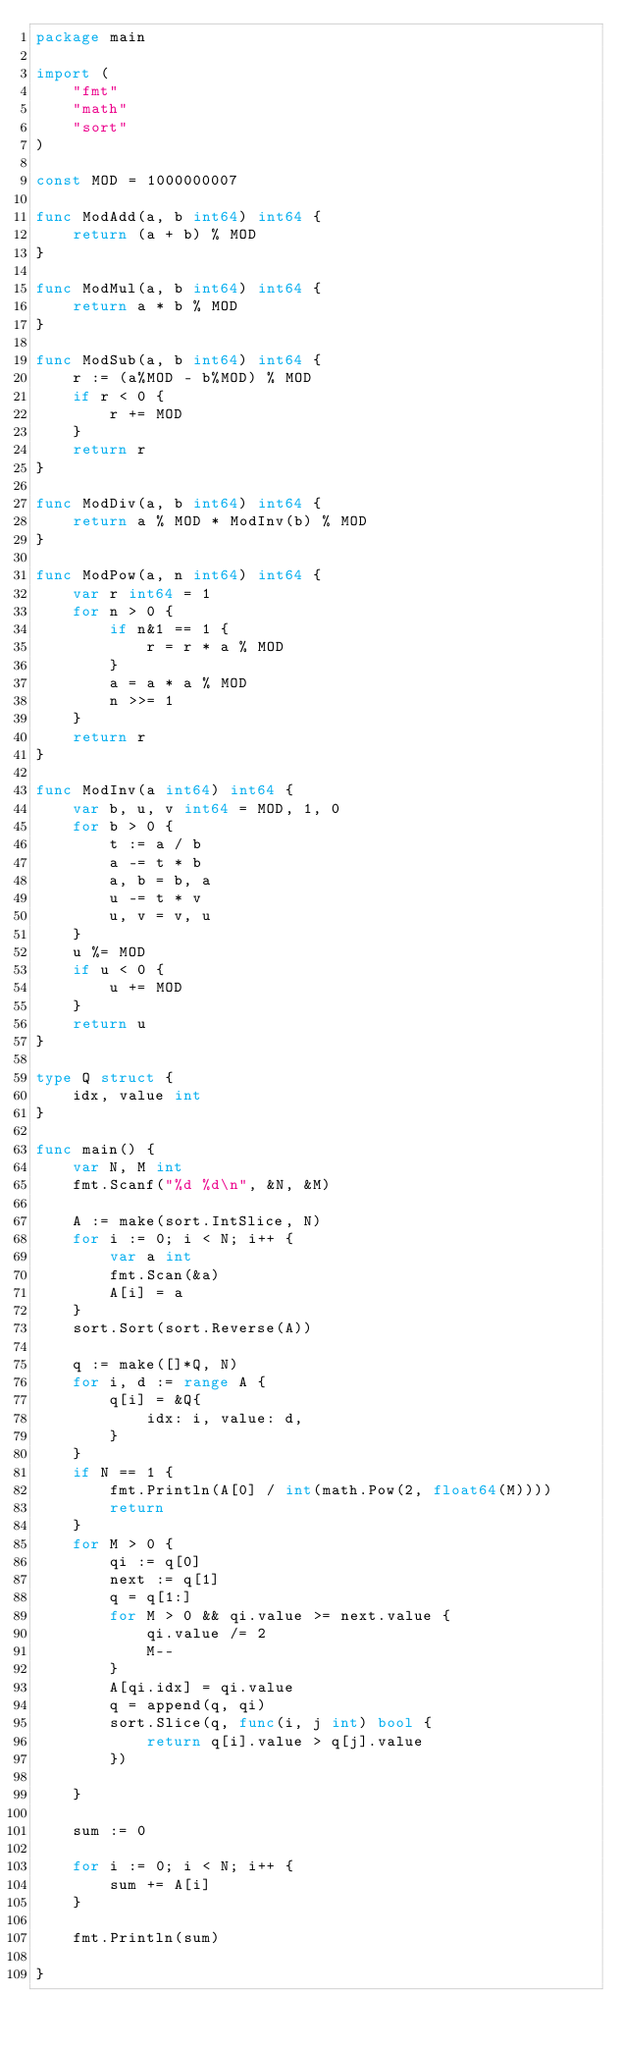Convert code to text. <code><loc_0><loc_0><loc_500><loc_500><_Go_>package main

import (
	"fmt"
	"math"
	"sort"
)

const MOD = 1000000007

func ModAdd(a, b int64) int64 {
	return (a + b) % MOD
}

func ModMul(a, b int64) int64 {
	return a * b % MOD
}

func ModSub(a, b int64) int64 {
	r := (a%MOD - b%MOD) % MOD
	if r < 0 {
		r += MOD
	}
	return r
}

func ModDiv(a, b int64) int64 {
	return a % MOD * ModInv(b) % MOD
}

func ModPow(a, n int64) int64 {
	var r int64 = 1
	for n > 0 {
		if n&1 == 1 {
			r = r * a % MOD
		}
		a = a * a % MOD
		n >>= 1
	}
	return r
}

func ModInv(a int64) int64 {
	var b, u, v int64 = MOD, 1, 0
	for b > 0 {
		t := a / b
		a -= t * b
		a, b = b, a
		u -= t * v
		u, v = v, u
	}
	u %= MOD
	if u < 0 {
		u += MOD
	}
	return u
}

type Q struct {
	idx, value int
}

func main() {
	var N, M int
	fmt.Scanf("%d %d\n", &N, &M)

	A := make(sort.IntSlice, N)
	for i := 0; i < N; i++ {
		var a int
		fmt.Scan(&a)
		A[i] = a
	}
	sort.Sort(sort.Reverse(A))

	q := make([]*Q, N)
	for i, d := range A {
		q[i] = &Q{
			idx: i, value: d,
		}
	}
	if N == 1 {
		fmt.Println(A[0] / int(math.Pow(2, float64(M))))
		return
	}
	for M > 0 {
		qi := q[0]
		next := q[1]
		q = q[1:]
		for M > 0 && qi.value >= next.value {
			qi.value /= 2
			M--
		}
		A[qi.idx] = qi.value
		q = append(q, qi)
		sort.Slice(q, func(i, j int) bool {
			return q[i].value > q[j].value
		})

	}

	sum := 0

	for i := 0; i < N; i++ {
		sum += A[i]
	}

	fmt.Println(sum)

}
</code> 